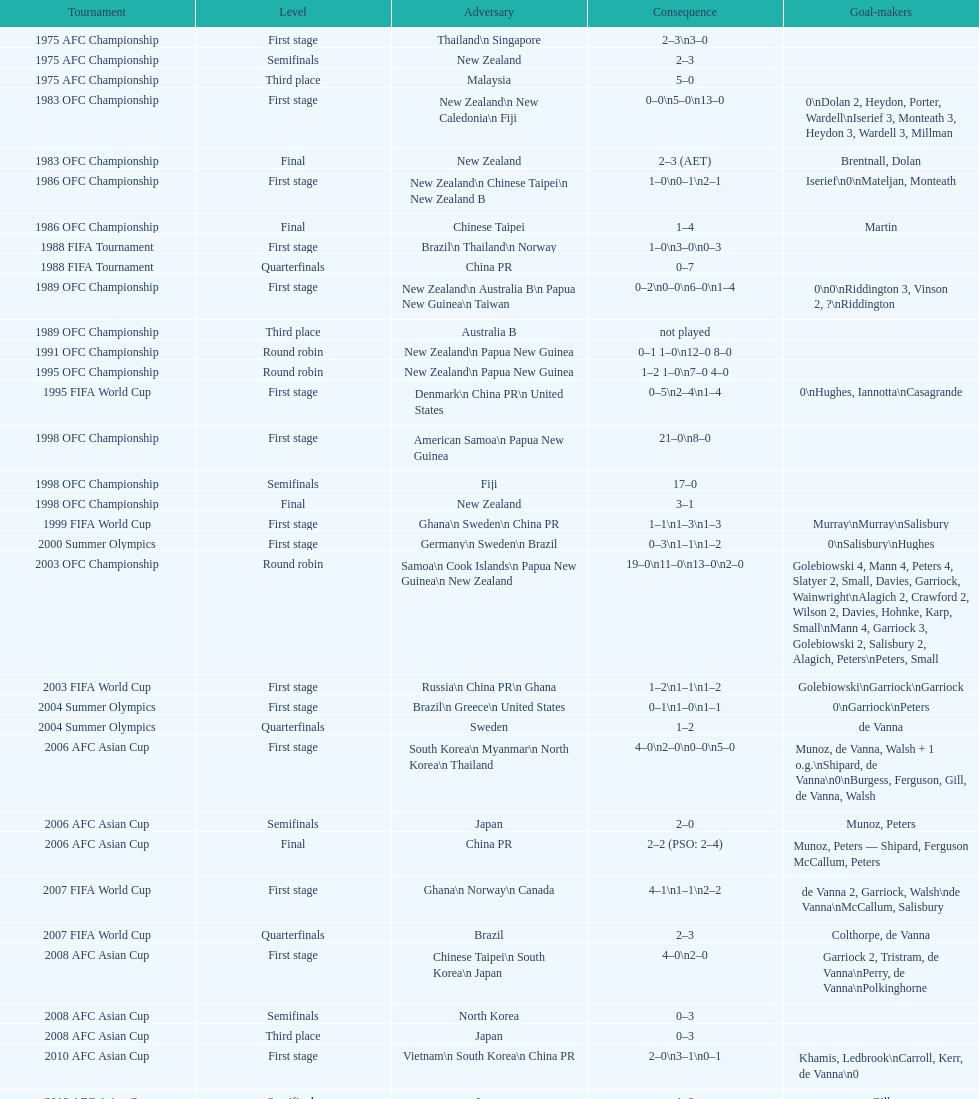What was the overall number of goals scored in the 1983 ofc championship? 18. 